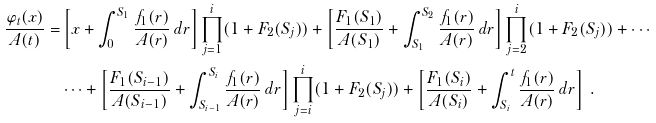<formula> <loc_0><loc_0><loc_500><loc_500>\frac { \varphi _ { t } ( x ) } { A ( t ) } = & \left [ x + \int _ { 0 } ^ { S _ { 1 } } \frac { f _ { 1 } ( r ) } { A ( r ) } \, d r \right ] \prod _ { j = 1 } ^ { i } ( 1 + F _ { 2 } ( S _ { j } ) ) + \left [ \frac { F _ { 1 } ( S _ { 1 } ) } { A ( S _ { 1 } ) } + \int _ { S _ { 1 } } ^ { S _ { 2 } } \frac { f _ { 1 } ( r ) } { A ( r ) } \, d r \right ] \prod _ { j = 2 } ^ { i } ( 1 + F _ { 2 } ( S _ { j } ) ) + \cdots \\ & \cdots + \left [ \frac { F _ { 1 } ( S _ { i - 1 } ) } { A ( S _ { i - 1 } ) } + \int _ { S _ { i - 1 } } ^ { S _ { i } } \frac { f _ { 1 } ( r ) } { A ( r ) } \, d r \right ] \prod _ { j = i } ^ { i } ( 1 + F _ { 2 } ( S _ { j } ) ) + \left [ \frac { F _ { 1 } ( S _ { i } ) } { A ( S _ { i } ) } + \int _ { S _ { i } } ^ { t } \frac { f _ { 1 } ( r ) } { A ( r ) } \, d r \right ] \ .</formula> 